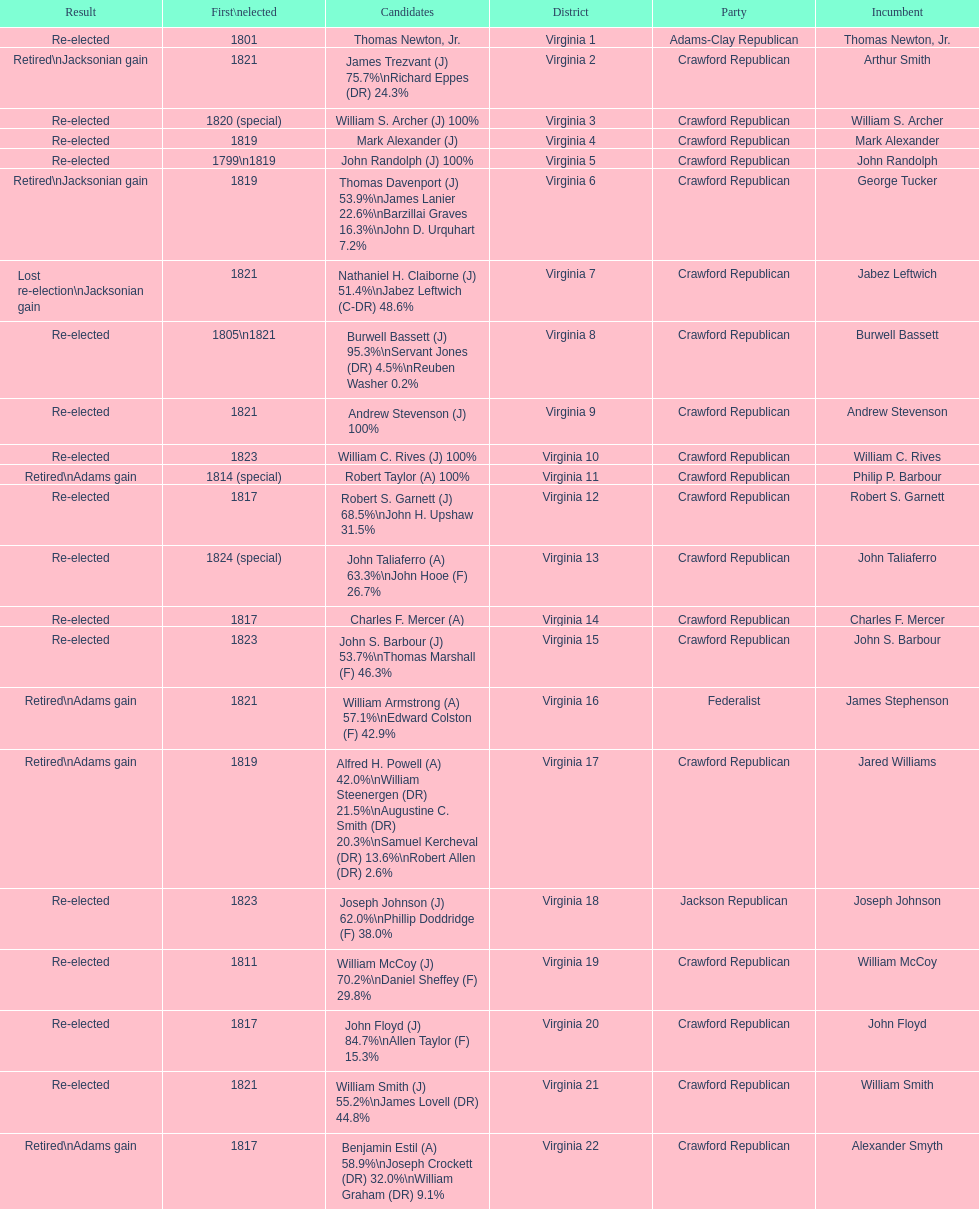What is the final party on this diagram? Crawford Republican. 